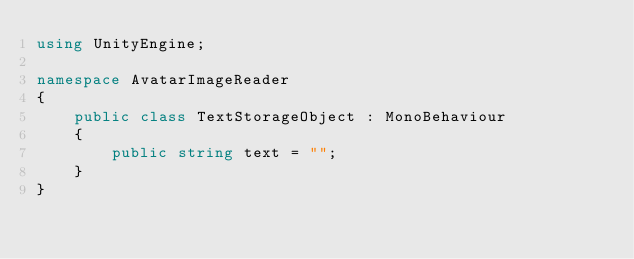<code> <loc_0><loc_0><loc_500><loc_500><_C#_>using UnityEngine;

namespace AvatarImageReader
{
    public class TextStorageObject : MonoBehaviour
    {
        public string text = "";
    }
}</code> 